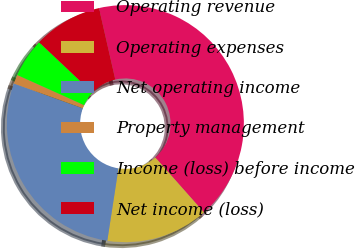Convert chart. <chart><loc_0><loc_0><loc_500><loc_500><pie_chart><fcel>Operating revenue<fcel>Operating expenses<fcel>Net operating income<fcel>Property management<fcel>Income (loss) before income<fcel>Net income (loss)<nl><fcel>42.04%<fcel>13.97%<fcel>28.07%<fcel>1.23%<fcel>5.31%<fcel>9.39%<nl></chart> 